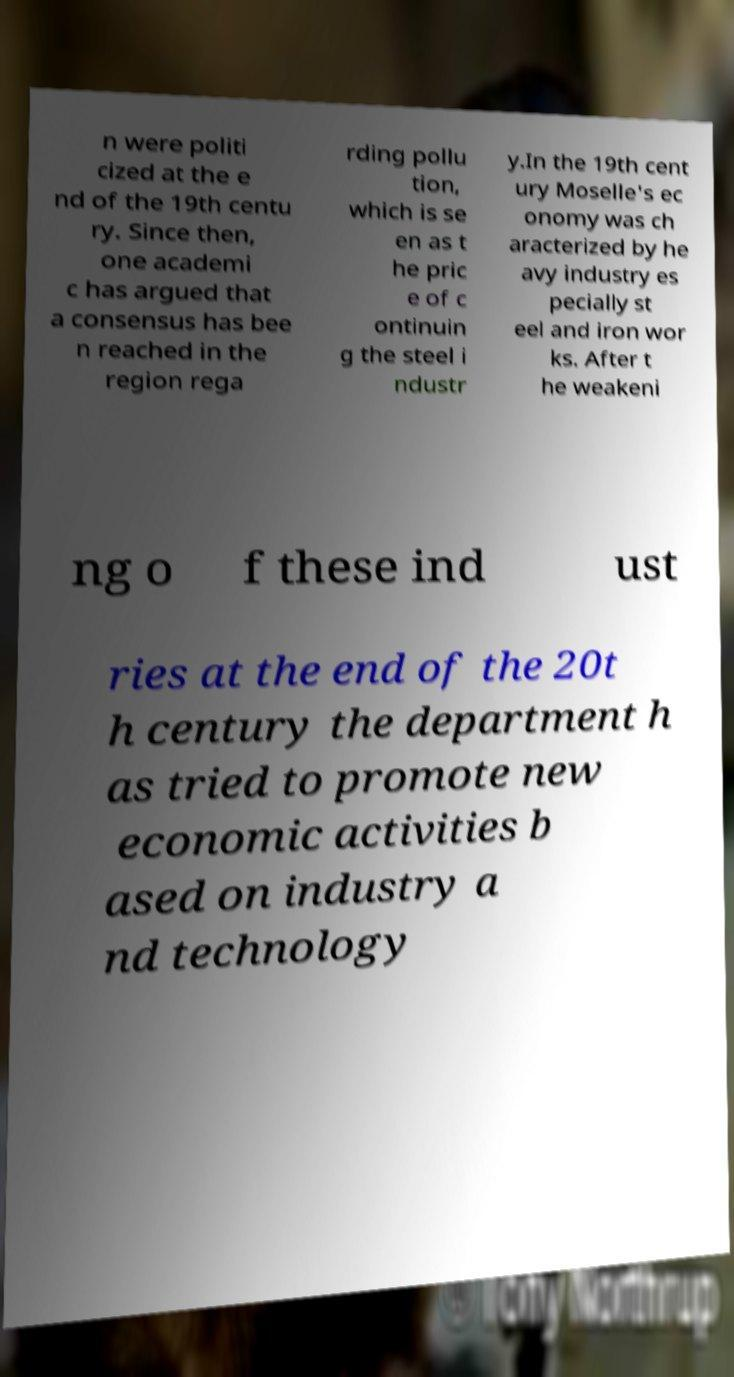Please identify and transcribe the text found in this image. n were politi cized at the e nd of the 19th centu ry. Since then, one academi c has argued that a consensus has bee n reached in the region rega rding pollu tion, which is se en as t he pric e of c ontinuin g the steel i ndustr y.In the 19th cent ury Moselle's ec onomy was ch aracterized by he avy industry es pecially st eel and iron wor ks. After t he weakeni ng o f these ind ust ries at the end of the 20t h century the department h as tried to promote new economic activities b ased on industry a nd technology 